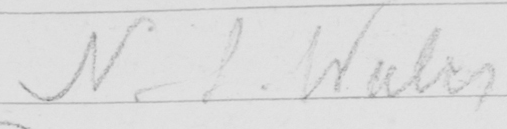What is written in this line of handwriting? N . S . Wales 